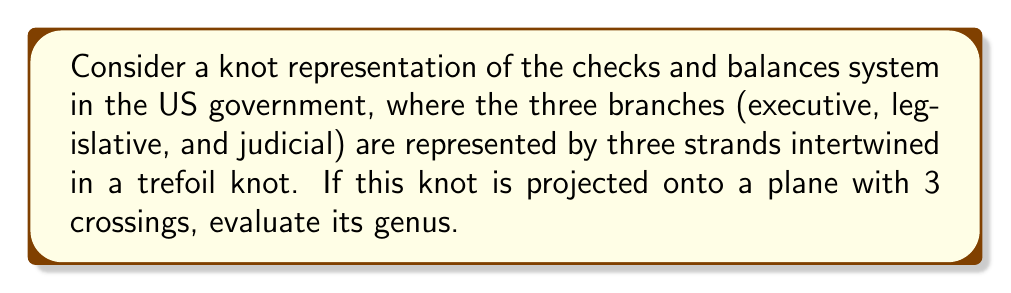What is the answer to this math problem? To determine the genus of this knot representation, we'll follow these steps:

1) First, recall the relationship between genus (g), number of crossings (n), and number of regions (r) in a knot diagram:

   $$r = n + 2 - 2g$$

2) In this case, we have a trefoil knot projection with 3 crossings, so n = 3.

3) To find the number of regions, we can use Euler's formula for planar graphs:

   $$V - E + F = 2$$

   Where V is the number of vertices (crossings), E is the number of edges, and F is the number of faces (regions).

4) In a knot diagram, each crossing creates 4 edges, so E = 4n/2 = 2n (we divide by 2 to avoid double-counting).

5) Substituting our known values:

   $$3 - 6 + r = 2$$
   $$r = 5$$

6) Now we can use our original equation:

   $$5 = 3 + 2 - 2g$$
   $$2g = 0$$
   $$g = 0$$

This result aligns with the fact that the trefoil knot is a genus-1 surface when embedded in 3D space, but its diagram on a plane (which is essentially a graph) has genus 0.
Answer: $g = 0$ 